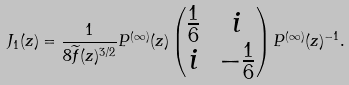Convert formula to latex. <formula><loc_0><loc_0><loc_500><loc_500>J _ { 1 } ( z ) = \frac { 1 } { 8 \widetilde { f } ( z ) ^ { 3 / 2 } } P ^ { ( \infty ) } ( z ) \begin{pmatrix} \frac { 1 } { 6 } & i \\ i & - \frac { 1 } { 6 } \\ \end{pmatrix} P ^ { ( \infty ) } ( z ) ^ { - 1 } .</formula> 